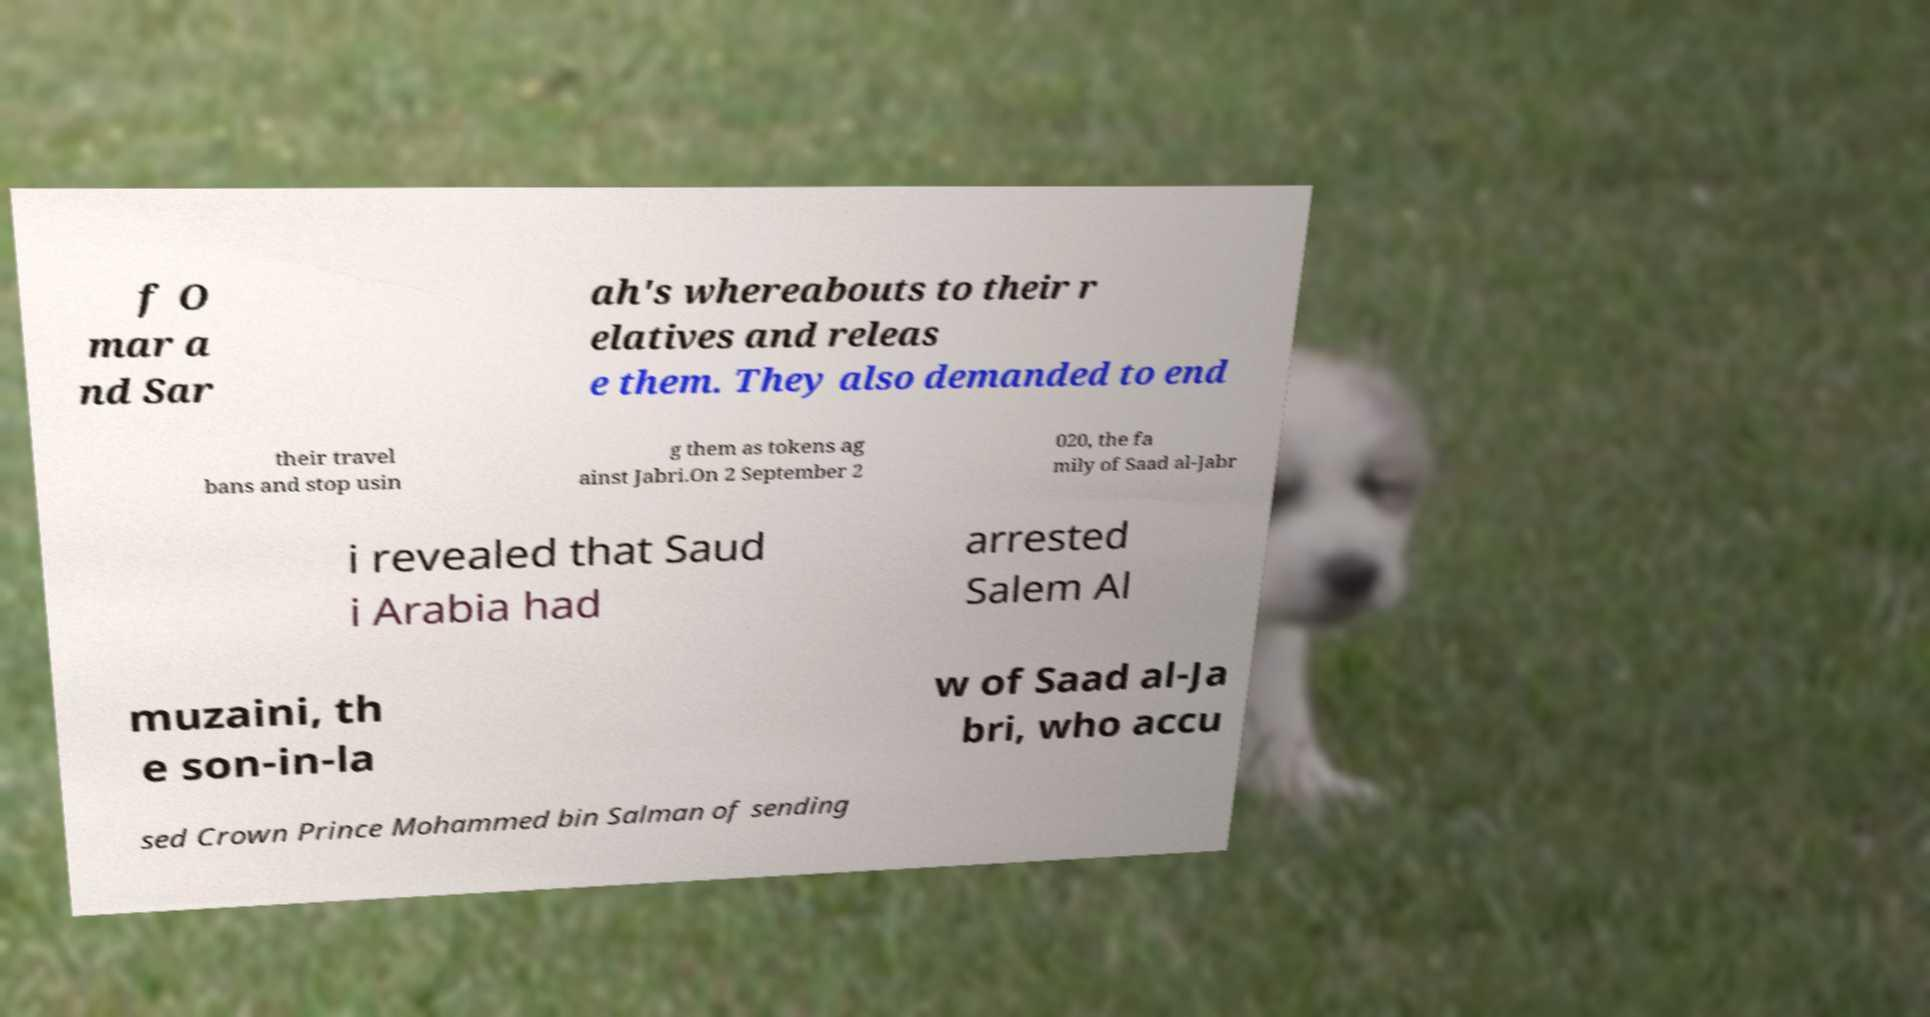For documentation purposes, I need the text within this image transcribed. Could you provide that? f O mar a nd Sar ah's whereabouts to their r elatives and releas e them. They also demanded to end their travel bans and stop usin g them as tokens ag ainst Jabri.On 2 September 2 020, the fa mily of Saad al-Jabr i revealed that Saud i Arabia had arrested Salem Al muzaini, th e son-in-la w of Saad al-Ja bri, who accu sed Crown Prince Mohammed bin Salman of sending 